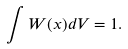<formula> <loc_0><loc_0><loc_500><loc_500>\int W ( { x } ) d V = 1 .</formula> 